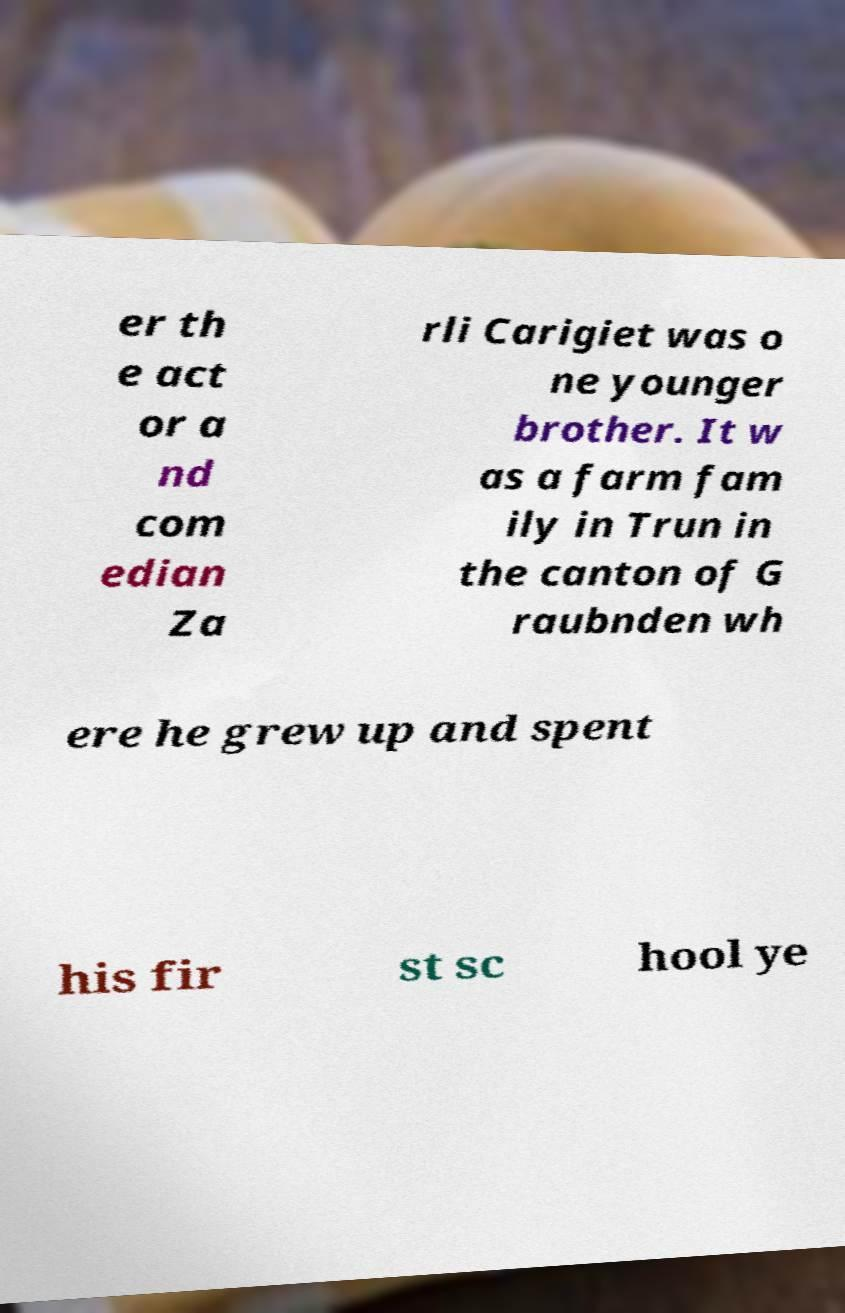Please identify and transcribe the text found in this image. er th e act or a nd com edian Za rli Carigiet was o ne younger brother. It w as a farm fam ily in Trun in the canton of G raubnden wh ere he grew up and spent his fir st sc hool ye 